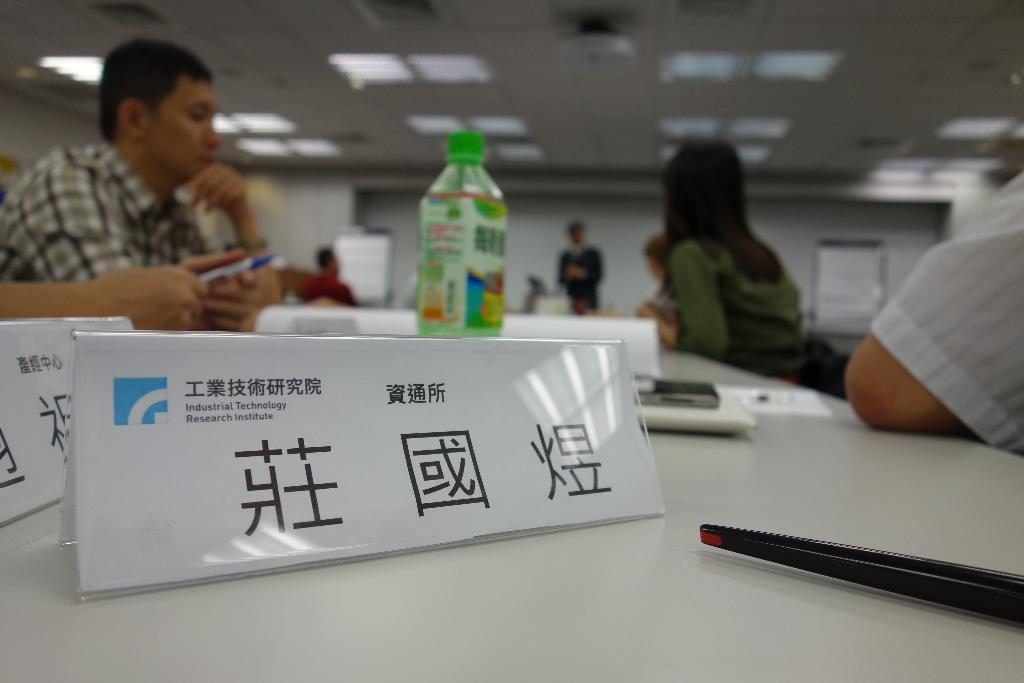Describe this image in one or two sentences. This is the table which is white in color. These are the name boards,bottle,mobile phone and few other things placed on the table. There are few people sitting. At background i can see a person standing. I think this is a projector, ceiling lights attached to the rooftop. 